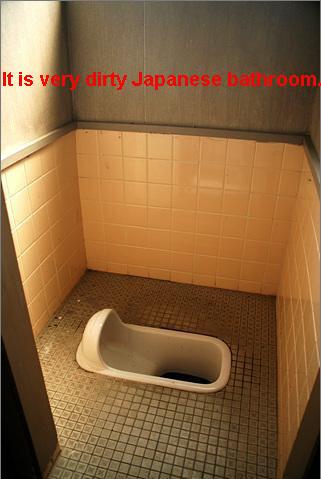What color is the bathroom?
Write a very short answer. White and gray. Where is this bathroom?
Answer briefly. Japan. Is the squat-type toilet?
Concise answer only. Yes. 